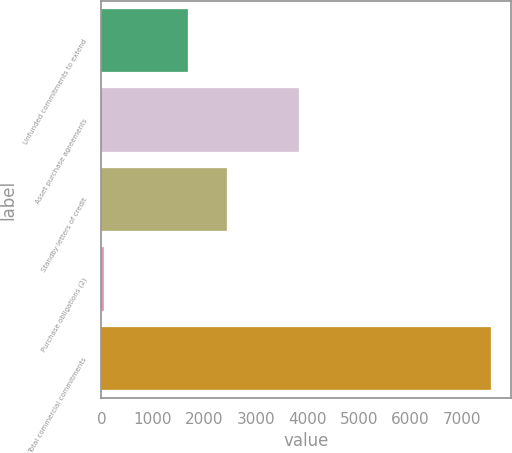Convert chart to OTSL. <chart><loc_0><loc_0><loc_500><loc_500><bar_chart><fcel>Unfunded commitments to extend<fcel>Asset purchase agreements<fcel>Standby letters of credit<fcel>Purchase obligations (2)<fcel>Total commercial commitments<nl><fcel>1691<fcel>3849<fcel>2444.4<fcel>45<fcel>7579<nl></chart> 